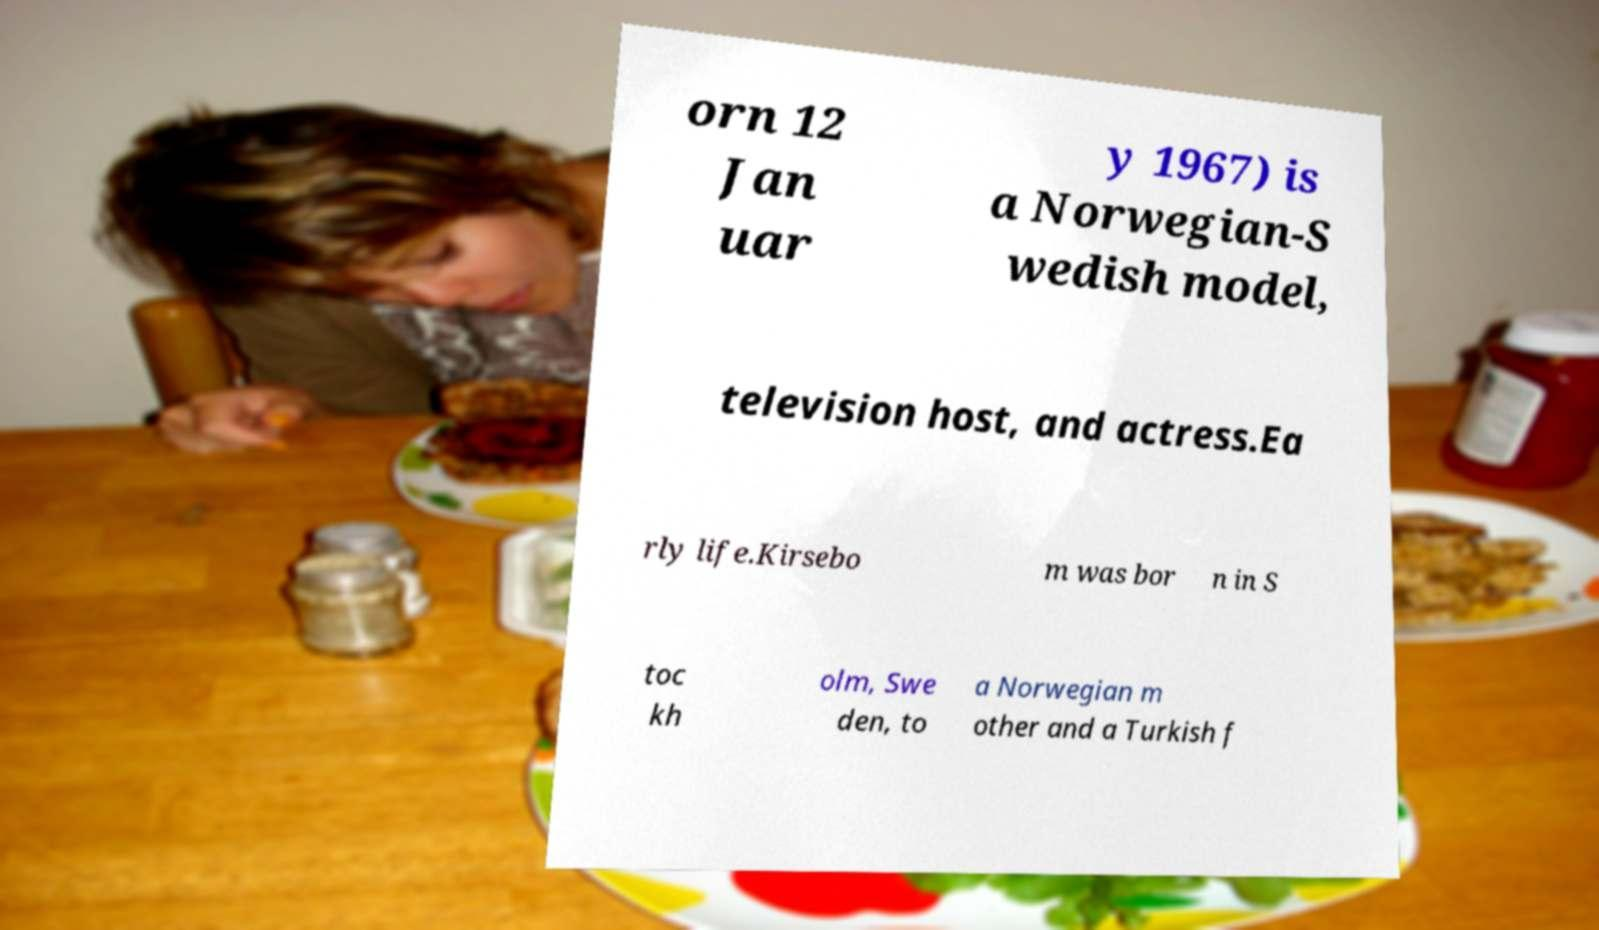Can you accurately transcribe the text from the provided image for me? orn 12 Jan uar y 1967) is a Norwegian-S wedish model, television host, and actress.Ea rly life.Kirsebo m was bor n in S toc kh olm, Swe den, to a Norwegian m other and a Turkish f 